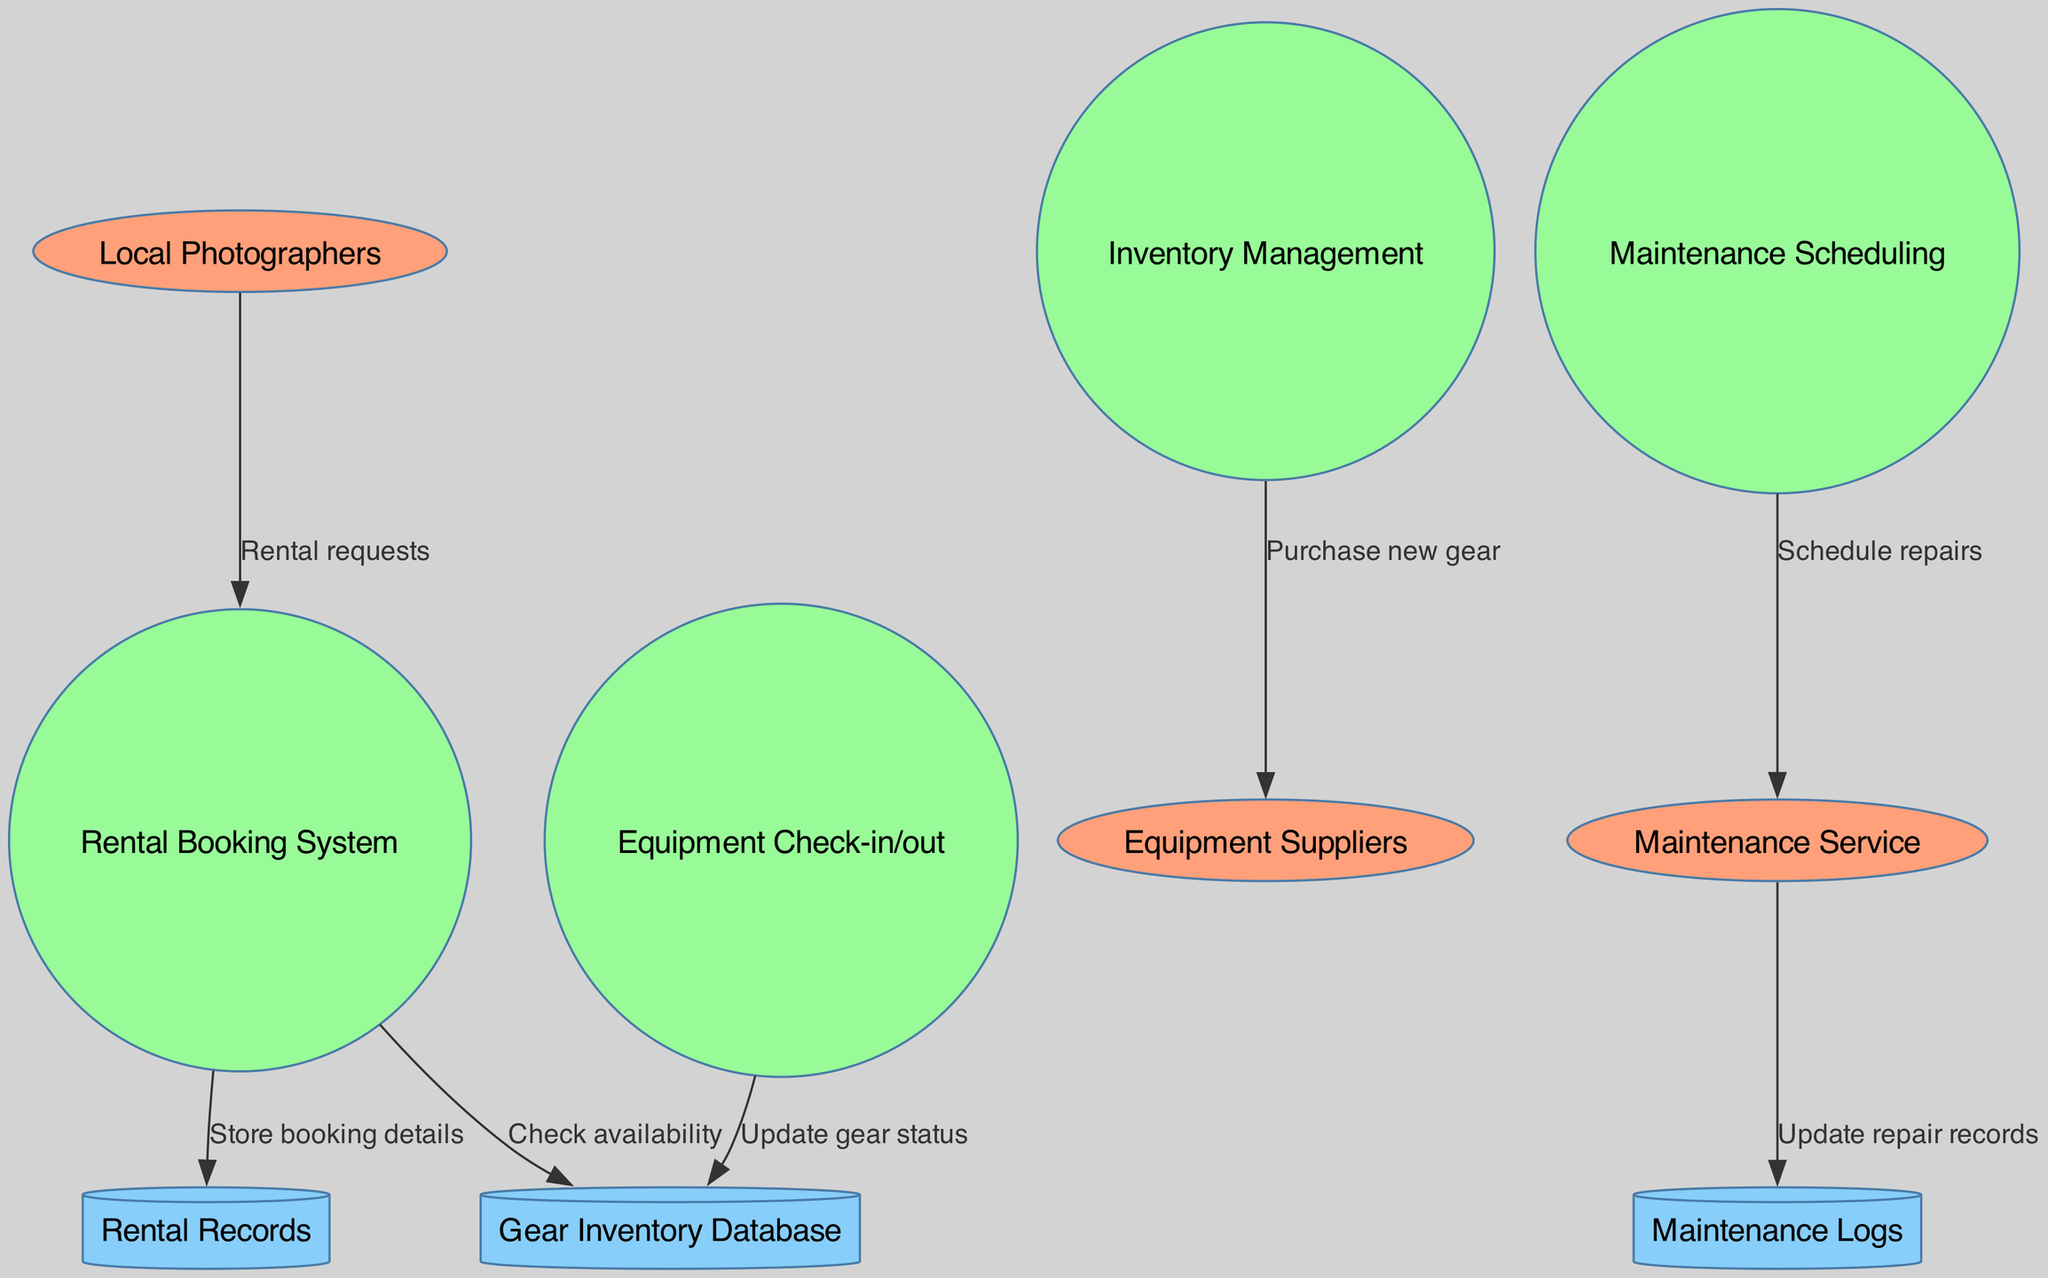What are the external entities in the diagram? The external entities listed in the diagram are Local Photographers, Equipment Suppliers, and Maintenance Service. They are represented as ellipses in the diagram, showing their role in the equipment rental and maintenance tracking process.
Answer: Local Photographers, Equipment Suppliers, Maintenance Service How many processes are depicted in the diagram? The diagram shows four processes: Rental Booking System, Inventory Management, Maintenance Scheduling, and Equipment Check-in/out. Each process is represented as a circle, indicating the various operations performed.
Answer: Four What data flow comes from the Rental Booking System? There are two data flows that come from the Rental Booking System: one flows to the Gear Inventory Database labeled "Check availability" and another to the Rental Records labeled "Store booking details". The arrows indicate the direction of data flow.
Answer: Check availability, Store booking details What does the Maintenance Scheduling process send to the Maintenance Service? The Maintenance Scheduling process sends a data flow labeled "Schedule repairs" to the Maintenance Service. This indicates that the scheduling of repairs is communicated to the service provider as part of the maintenance management process.
Answer: Schedule repairs Which data store is updated by the Equipment Check-in/out process? The Equipment Check-in/out process updates the Gear Inventory Database. This is crucial as it reflects the current status of the rented equipment, ensuring accurate tracking and management of gear availability.
Answer: Gear Inventory Database What relationship exists between Maintenance Service and Maintenance Logs? The relationship is that the Maintenance Service updates the Maintenance Logs with new information when repairs are completed. This indicates a connection where maintenance activities are recorded for tracking purposes.
Answer: Update repair records Which process requests rental information from local photographers? The Rental Booking System requests rental information from Local Photographers via the data flow labeled "Rental requests". This indicates how the system interacts with users to facilitate rental bookings.
Answer: Rental Booking System What action does the Inventory Management process take regarding Equipment Suppliers? The Inventory Management process takes the action of purchasing new gear from Equipment Suppliers. This flow indicates that when inventory is low or new equipment is needed, a request or order is communicated to suppliers.
Answer: Purchase new gear 